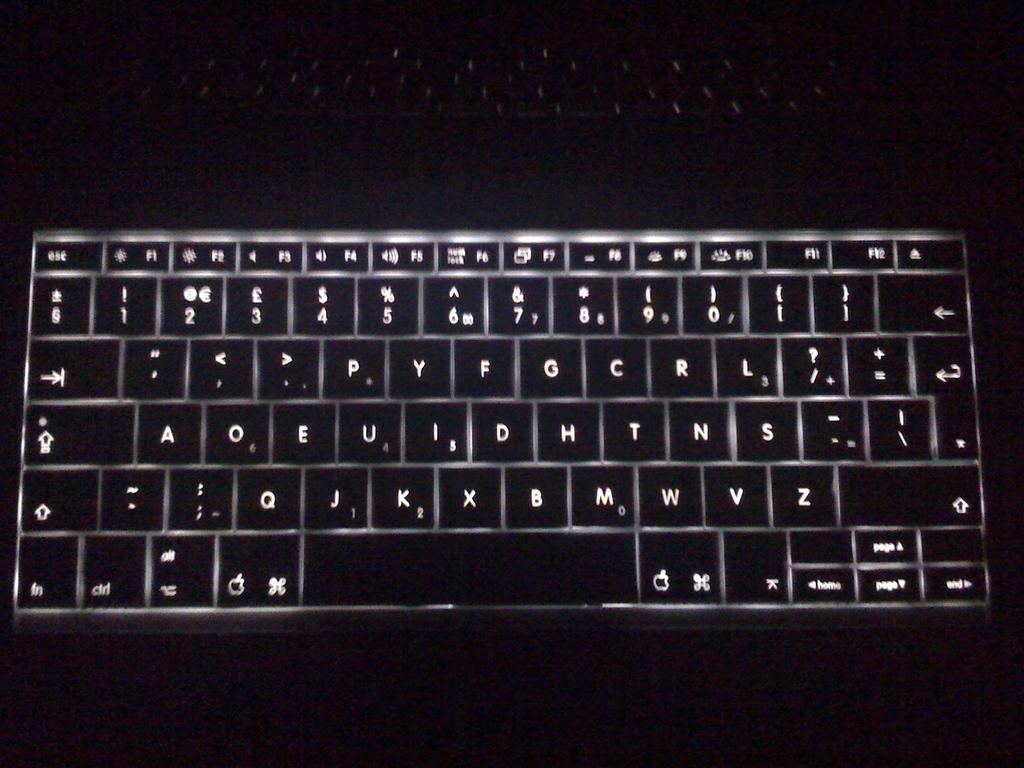Provide a one-sentence caption for the provided image. A keyboard that shows numbers and letters A through Z all in the color white. 